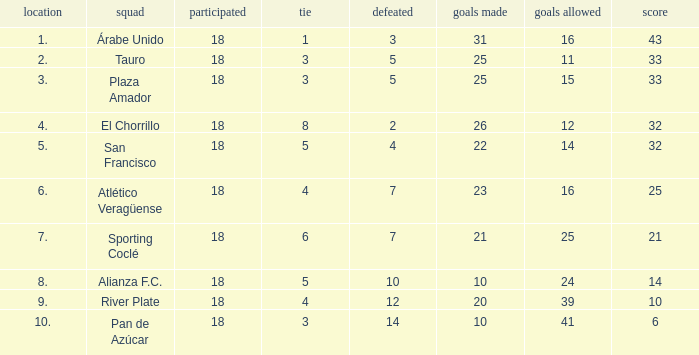How many goals were conceded by the team with more than 21 points more than 5 draws and less than 18 games played? None. 